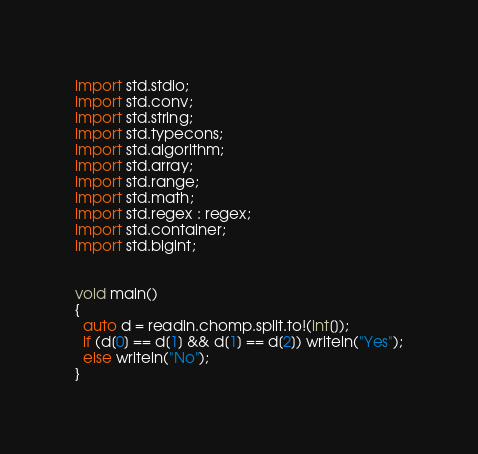Convert code to text. <code><loc_0><loc_0><loc_500><loc_500><_D_>import std.stdio;
import std.conv;
import std.string;
import std.typecons;
import std.algorithm;
import std.array;
import std.range;
import std.math;
import std.regex : regex;
import std.container;
import std.bigint;


void main()
{
  auto d = readln.chomp.split.to!(int[]);
  if (d[0] == d[1] && d[1] == d[2]) writeln("Yes");
  else writeln("No");
}
</code> 